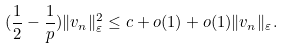<formula> <loc_0><loc_0><loc_500><loc_500>( \frac { 1 } { 2 } - \frac { 1 } { p } ) \| v _ { n } \| ^ { 2 } _ { \varepsilon } \leq c + o ( 1 ) + o ( 1 ) \| v _ { n } \| _ { \varepsilon } .</formula> 